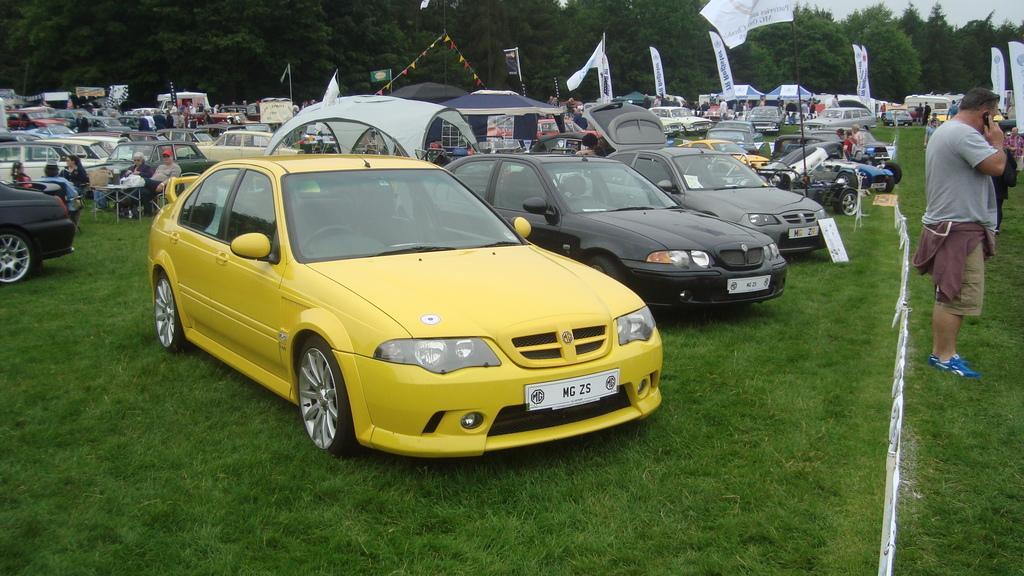Describe this image in one or two sentences. This picture contains many cars which are parked in the garden. On the left side of the picture, there are people sitting on the chairs. There are flags and banners in the background. There are trees in the background. At the bottom of the picture, we see the grass, The man on the right side is holding a mobile phone in his hand and he is talking on the phone. 